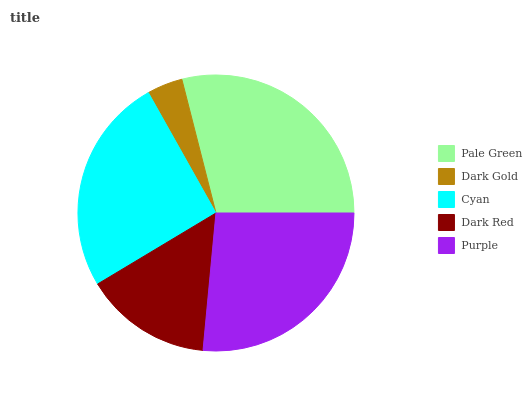Is Dark Gold the minimum?
Answer yes or no. Yes. Is Pale Green the maximum?
Answer yes or no. Yes. Is Cyan the minimum?
Answer yes or no. No. Is Cyan the maximum?
Answer yes or no. No. Is Cyan greater than Dark Gold?
Answer yes or no. Yes. Is Dark Gold less than Cyan?
Answer yes or no. Yes. Is Dark Gold greater than Cyan?
Answer yes or no. No. Is Cyan less than Dark Gold?
Answer yes or no. No. Is Cyan the high median?
Answer yes or no. Yes. Is Cyan the low median?
Answer yes or no. Yes. Is Dark Red the high median?
Answer yes or no. No. Is Dark Red the low median?
Answer yes or no. No. 